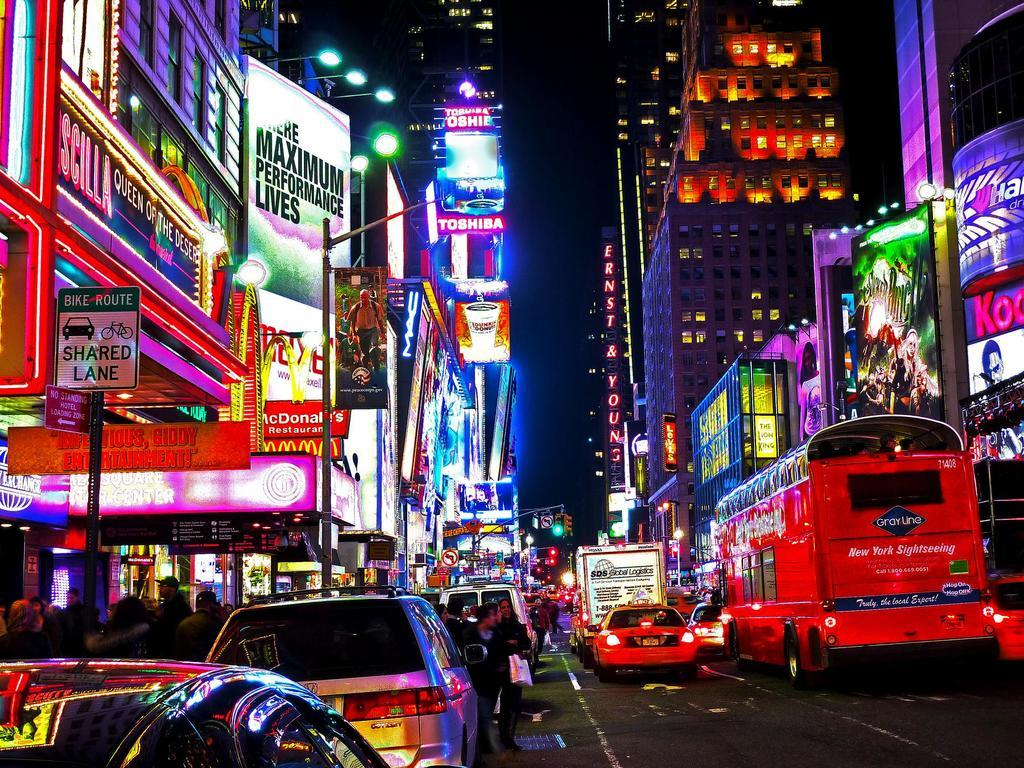<image>
Write a terse but informative summary of the picture. A red GrayLine bus drives down a busy street. 